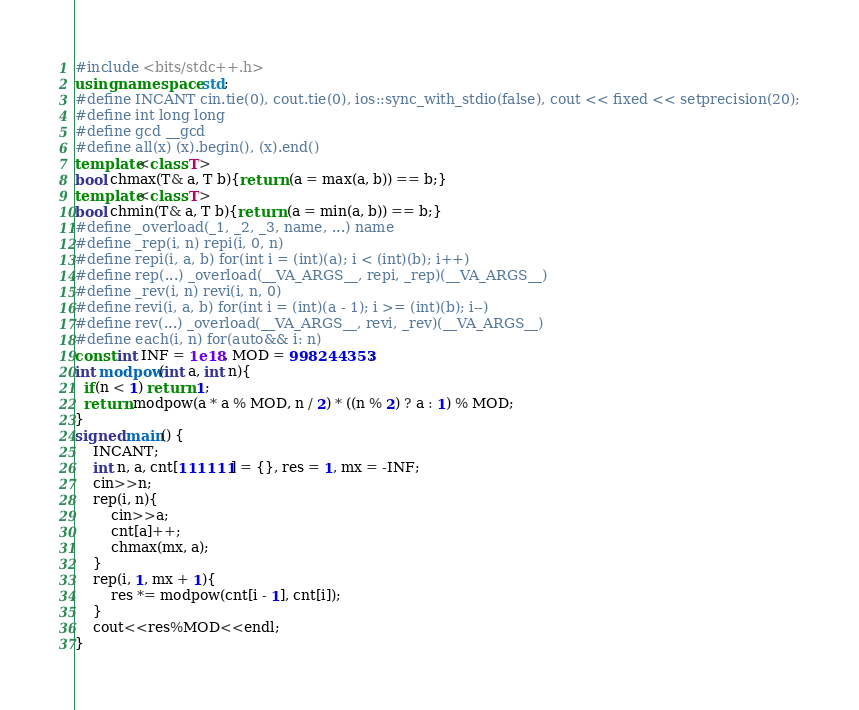<code> <loc_0><loc_0><loc_500><loc_500><_C++_>#include <bits/stdc++.h>
using namespace std;
#define INCANT cin.tie(0), cout.tie(0), ios::sync_with_stdio(false), cout << fixed << setprecision(20);
#define int long long
#define gcd __gcd
#define all(x) (x).begin(), (x).end()
template<class T>
bool chmax(T& a, T b){return (a = max(a, b)) == b;}
template<class T>
bool chmin(T& a, T b){return (a = min(a, b)) == b;}
#define _overload(_1, _2, _3, name, ...) name
#define _rep(i, n) repi(i, 0, n)
#define repi(i, a, b) for(int i = (int)(a); i < (int)(b); i++)
#define rep(...) _overload(__VA_ARGS__, repi, _rep)(__VA_ARGS__)
#define _rev(i, n) revi(i, n, 0)
#define revi(i, a, b) for(int i = (int)(a - 1); i >= (int)(b); i--)
#define rev(...) _overload(__VA_ARGS__, revi, _rev)(__VA_ARGS__)
#define each(i, n) for(auto&& i: n)
const int INF = 1e18, MOD = 998244353;
int modpow(int a, int n){
  if(n < 1) return 1;
  return modpow(a * a % MOD, n / 2) * ((n % 2) ? a : 1) % MOD;
}
signed main() {
    INCANT;
    int n, a, cnt[111111] = {}, res = 1, mx = -INF;
    cin>>n;
    rep(i, n){
        cin>>a;
        cnt[a]++;
        chmax(mx, a);
    }
    rep(i, 1, mx + 1){
        res *= modpow(cnt[i - 1], cnt[i]);
    }
    cout<<res%MOD<<endl;
}
</code> 